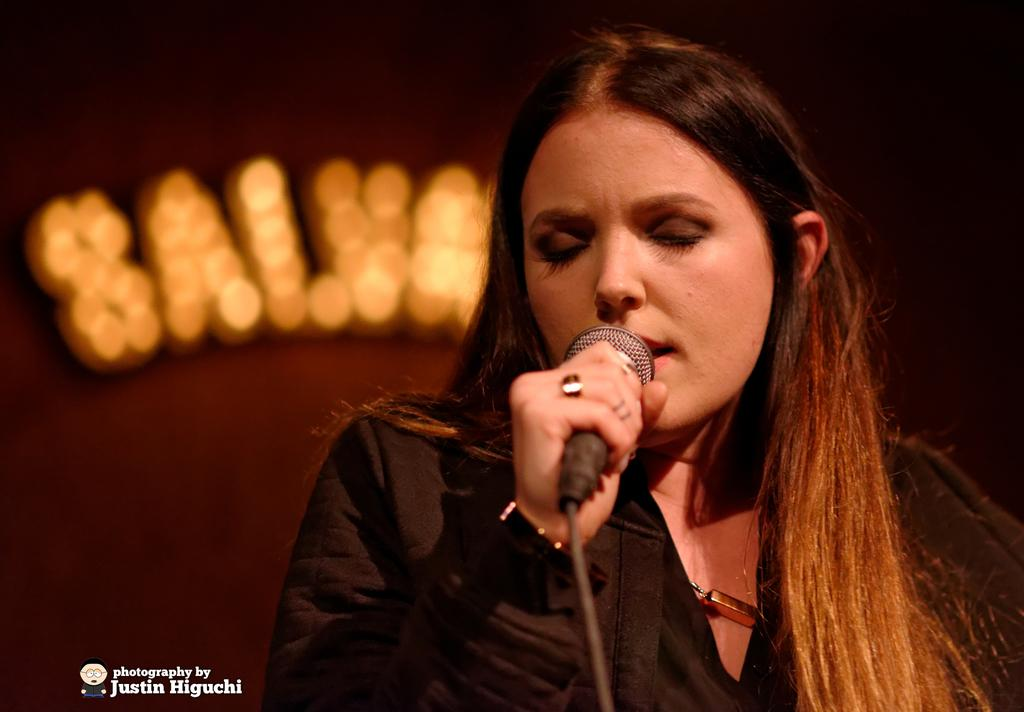Who is the main subject in the image? There is a woman in the image. What is the woman wearing? The woman is wearing a black dress. What is the woman holding in the image? The woman is holding a mic. What might the woman be doing in the image? The woman may be singing, as she is holding a mic. What can be seen in the background of the image? There is a text with lights in the background of the image. What type of fowl can be seen in the image? There is no fowl present in the image. Is the woman in the image working in an office? The image does not provide any information about the location or setting being an office. 